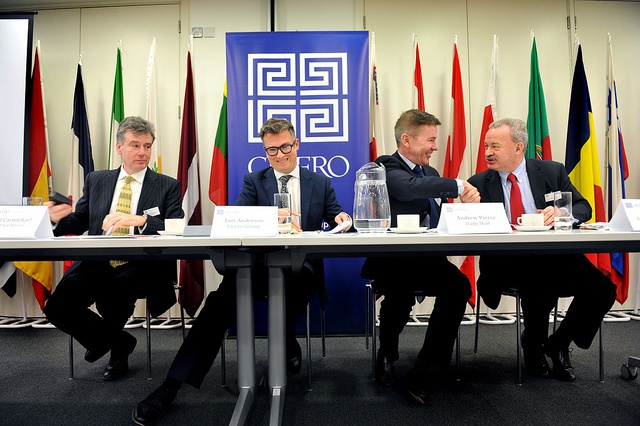Describe the objects in this image and their specific colors. I can see people in black, white, darkgray, and gray tones, people in black, ivory, gray, and tan tones, people in black, salmon, lavender, and tan tones, people in black, navy, ivory, and salmon tones, and chair in black, gray, darkgray, and beige tones in this image. 